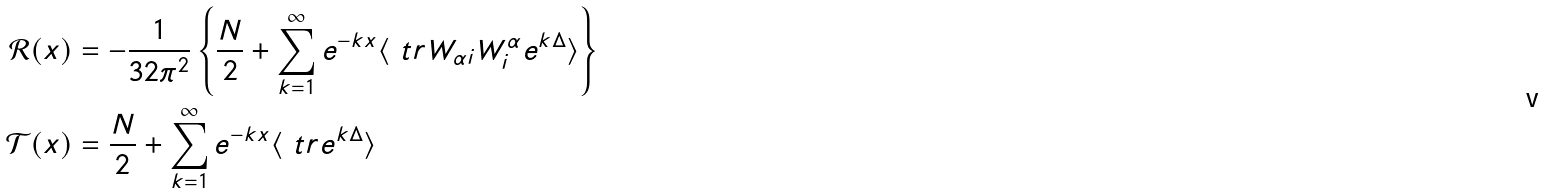<formula> <loc_0><loc_0><loc_500><loc_500>\mathcal { R } ( x ) & = - \frac { 1 } { 3 2 \pi ^ { 2 } } \left \{ \frac { N } { 2 } + \sum _ { k = 1 } ^ { \infty } e ^ { - k x } \langle \ t r W _ { \alpha i } W ^ { \alpha } _ { i } e ^ { k \Delta } \rangle \right \} \\ \mathcal { T } ( x ) & = \frac { N } { 2 } + \sum _ { k = 1 } ^ { \infty } e ^ { - k x } \langle \ t r e ^ { k \Delta } \rangle</formula> 